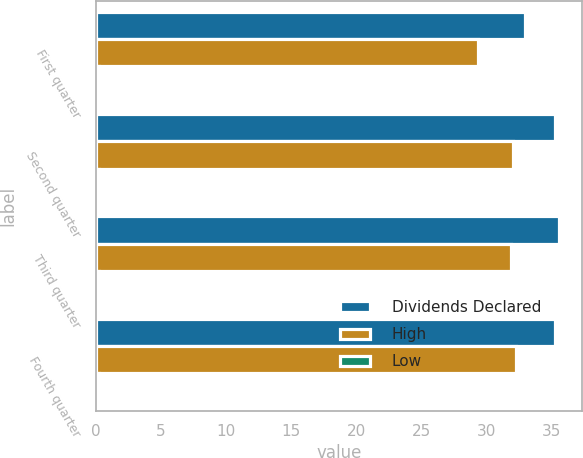<chart> <loc_0><loc_0><loc_500><loc_500><stacked_bar_chart><ecel><fcel>First quarter<fcel>Second quarter<fcel>Third quarter<fcel>Fourth quarter<nl><fcel>Dividends Declared<fcel>33.01<fcel>35.28<fcel>35.61<fcel>35.29<nl><fcel>High<fcel>29.34<fcel>32.07<fcel>31.94<fcel>32.29<nl><fcel>Low<fcel>0.23<fcel>0.23<fcel>0.26<fcel>0.26<nl></chart> 